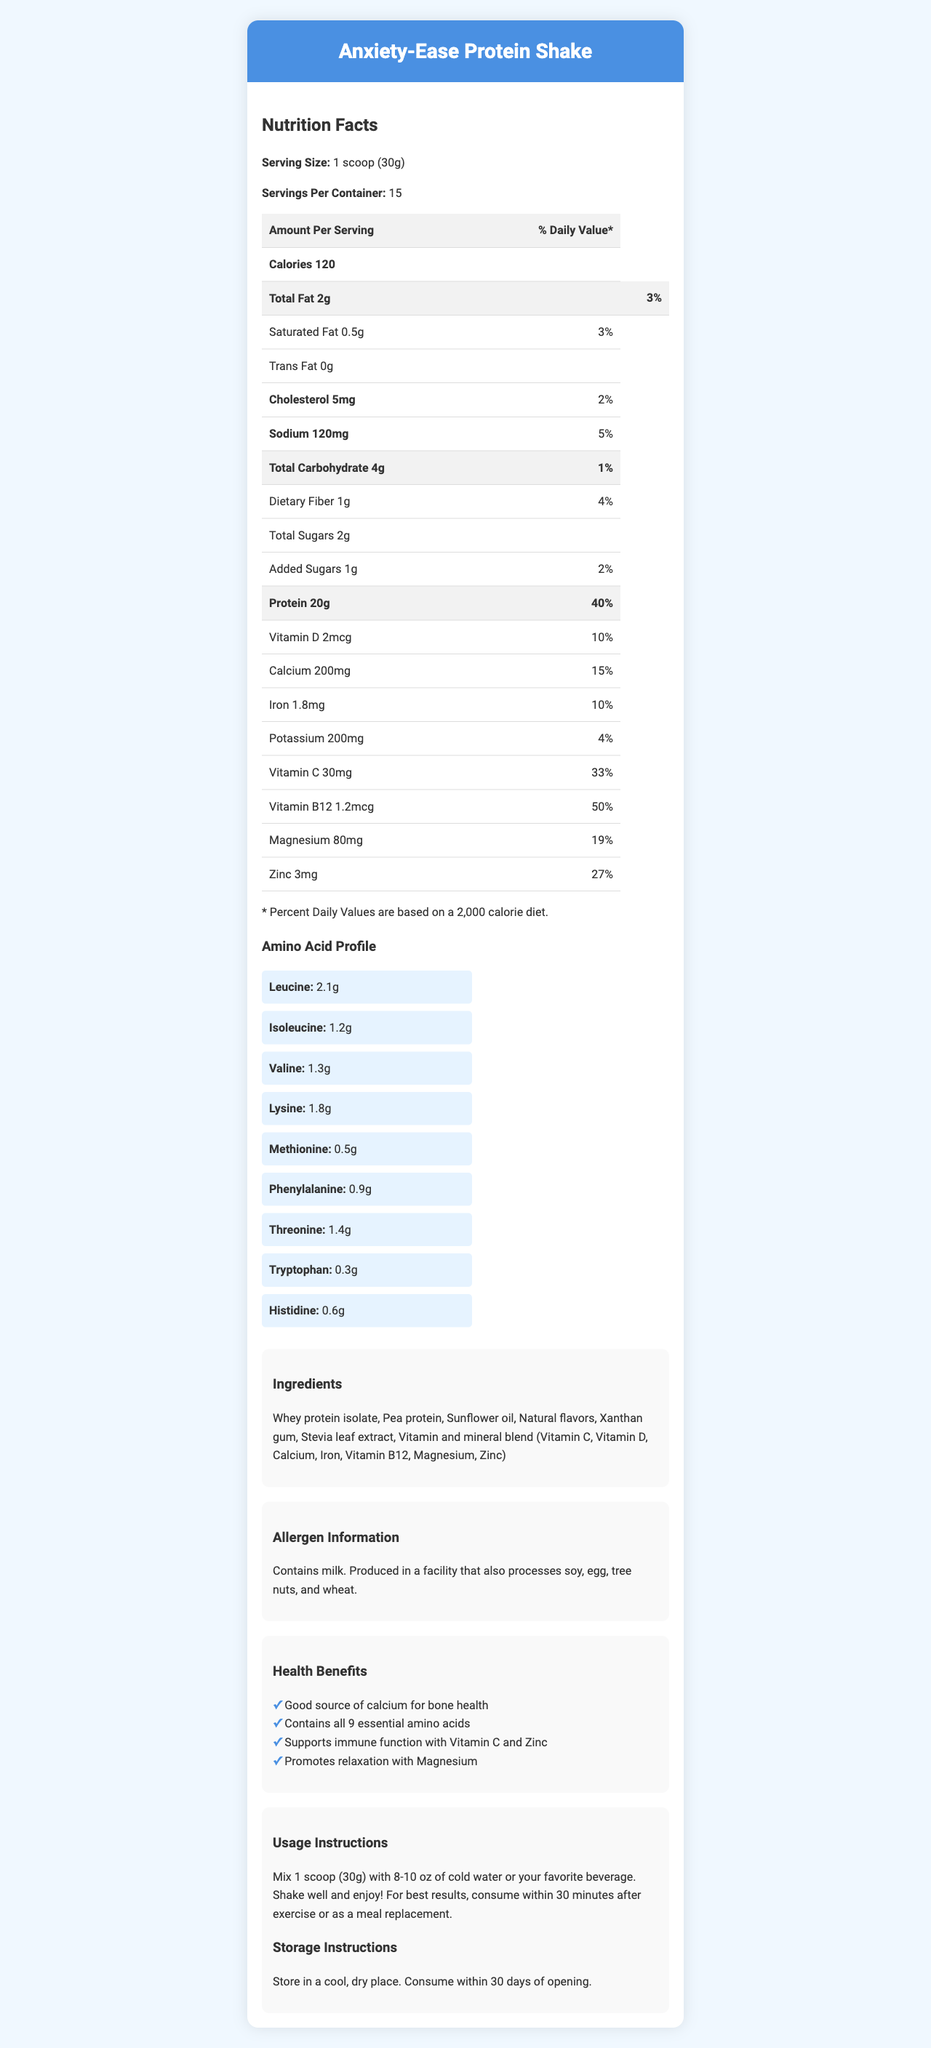what is the serving size for Anxiety-Ease Protein Shake? The serving size is clearly mentioned in the Nutrition Facts section of the document as "1 scoop (30g)".
Answer: 1 scoop (30g) how many calories are there in one serving? The Nutrition Facts section lists the calories per serving as 120.
Answer: 120 how much protein does one serving contain? According to the document, the protein content per serving is 20g.
Answer: 20g what is the percentage daily value of Vitamin B12 per serving? The document shows that the daily value percentage for Vitamin B12 is 50%.
Answer: 50% List 3 ingredients found in the Anxiety-Ease Protein Shake The ingredients listed in the Ingredients section include Whey protein isolate, Pea protein, Sunflower oil.
Answer: Whey protein isolate, Pea protein, Sunflower oil how much zinc is in one serving? The amount of zinc per serving is shown to be 3mg.
Answer: 3mg is there any cholesterol in the shake? The document states there is 5mg of cholesterol per serving.
Answer: Yes how many grams of leucine does the shake contain? Leucine content is given as 2.1g in the Amino Acid Profile section.
Answer: 2.1g which vitamin is included in the shake to support immune function? A. Vitamin A B. Vitamin C C. Vitamin D D. Vitamin E The Health Claims section states that Vitamin C supports immune function.
Answer: B how many essential amino acids does the shake contain? A. 6 B. 7 C. 8 D. 9 The document claims that the product contains all 9 essential amino acids.
Answer: D is it safe for people with nut allergies to consume this shake? The allergen information mentions that the product is produced in a facility that processes tree nuts, which might pose a risk.
Answer: No summarize the main health benefits of the Anxiety-Ease Protein Shake The Health Claims section outlines these primary benefits.
Answer: Good source of calcium for bone health, supports immune function with Vitamin C and Zinc, promotes relaxation with Magnesium, contains all 9 essential amino acids how should the product be stored after opening? The Storage Instructions section indicates the storage requirements.
Answer: Store in a cool, dry place. Consume within 30 days of opening. how much sodium does one serving contain? The Sodium content per serving is given as 120mg.
Answer: 120mg what's the total carbohydrate content per serving? The document lists 4g as the total carbohydrate content per serving.
Answer: 4g how long after exercise should the shake be consumed for best results? The Usage Instructions recommend consuming the shake within 30 minutes after exercise.
Answer: Within 30 minutes is there any added sugar in the shake? The document shows there is 1g of added sugars per serving.
Answer: Yes how many servings are there in one container? The Servings Per Container section states that there are 15 servings per container.
Answer: 15 does the shake contain soy? The allergen information does not list soy as an ingredient but mentions the product is manufactured in a facility that processes soy. The exact presence of soy cannot be determined.
Answer: Cannot be determined 